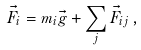Convert formula to latex. <formula><loc_0><loc_0><loc_500><loc_500>\vec { F } _ { i } = m _ { i } \vec { g } + \sum _ { j } \vec { F } _ { i j } \, ,</formula> 